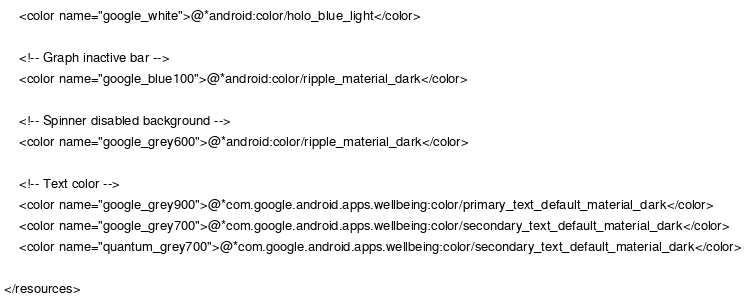Convert code to text. <code><loc_0><loc_0><loc_500><loc_500><_XML_>    <color name="google_white">@*android:color/holo_blue_light</color>

    <!-- Graph inactive bar -->
    <color name="google_blue100">@*android:color/ripple_material_dark</color>

    <!-- Spinner disabled background -->
    <color name="google_grey600">@*android:color/ripple_material_dark</color>

    <!-- Text color -->
    <color name="google_grey900">@*com.google.android.apps.wellbeing:color/primary_text_default_material_dark</color>
    <color name="google_grey700">@*com.google.android.apps.wellbeing:color/secondary_text_default_material_dark</color>
    <color name="quantum_grey700">@*com.google.android.apps.wellbeing:color/secondary_text_default_material_dark</color>

</resources>
</code> 